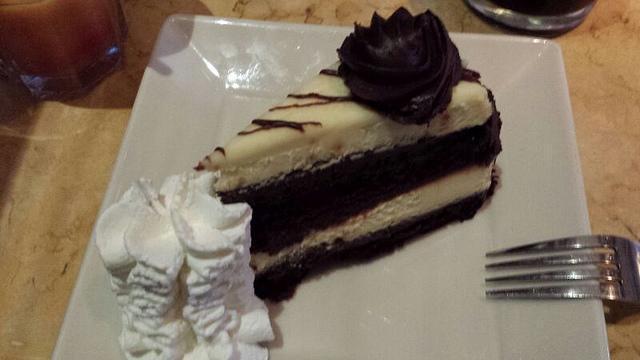How many cups can be seen?
Give a very brief answer. 2. 